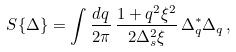Convert formula to latex. <formula><loc_0><loc_0><loc_500><loc_500>S \{ \Delta \} = \int \frac { d q } { 2 \pi } \, \frac { 1 + q ^ { 2 } \xi ^ { 2 } } { 2 \Delta _ { s } ^ { 2 } \xi } \, \Delta _ { q } ^ { \ast } \Delta _ { q } \, ,</formula> 